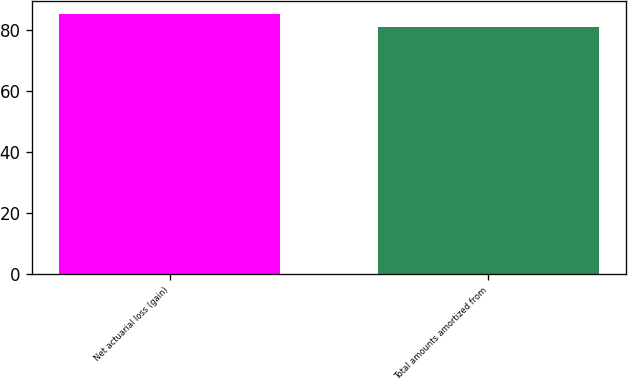Convert chart to OTSL. <chart><loc_0><loc_0><loc_500><loc_500><bar_chart><fcel>Net actuarial loss (gain)<fcel>Total amounts amortized from<nl><fcel>85<fcel>81<nl></chart> 